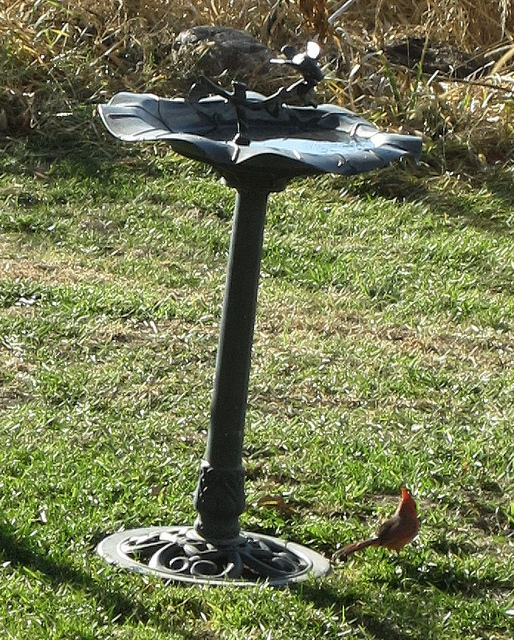<image>Where is the bird looking? I am not sure where the bird is looking. It might be looking up, at the grass, or away from the camera. Where is the bird looking? I don't know where the bird is looking. It can be looking at the grass, up, away from the camera, or left. 